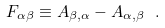<formula> <loc_0><loc_0><loc_500><loc_500>F _ { \alpha \beta } \equiv A _ { \beta , \alpha } - A _ { \alpha , \beta } \ .</formula> 